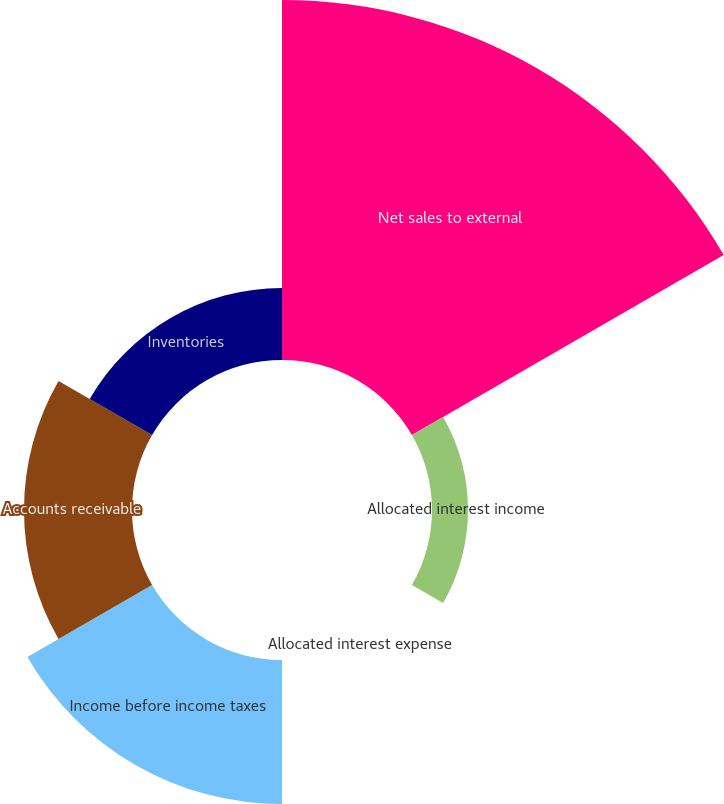<chart> <loc_0><loc_0><loc_500><loc_500><pie_chart><fcel>Net sales to external<fcel>Allocated interest income<fcel>Allocated interest expense<fcel>Income before income taxes<fcel>Accounts receivable<fcel>Inventories<nl><fcel>49.99%<fcel>5.0%<fcel>0.0%<fcel>20.0%<fcel>15.0%<fcel>10.0%<nl></chart> 